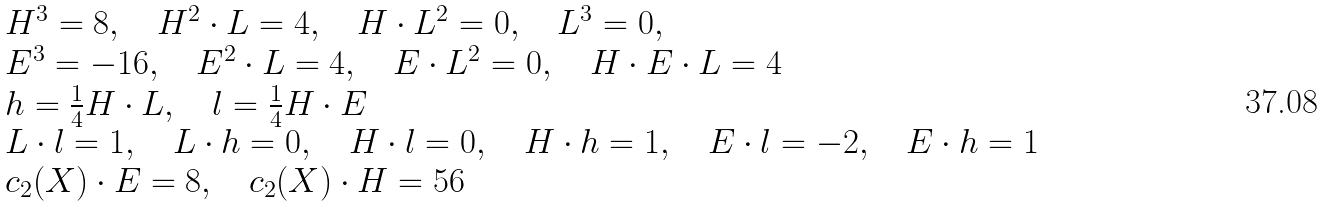<formula> <loc_0><loc_0><loc_500><loc_500>\begin{array} { l } H ^ { 3 } = 8 , \quad H ^ { 2 } \cdot L = 4 , \quad H \cdot L ^ { 2 } = 0 , \quad L ^ { 3 } = 0 , \\ E ^ { 3 } = - 1 6 , \quad E ^ { 2 } \cdot L = 4 , \quad E \cdot L ^ { 2 } = 0 , \quad H \cdot E \cdot L = 4 \\ h = \frac { 1 } { 4 } H \cdot L , \quad l = \frac { 1 } { 4 } H \cdot E \\ L \cdot l = 1 , \quad L \cdot h = 0 , \quad H \cdot l = 0 , \quad H \cdot h = 1 , \quad E \cdot l = - 2 , \quad E \cdot h = 1 \\ c _ { 2 } ( X ) \cdot E = 8 , \quad c _ { 2 } ( X ) \cdot H = 5 6 \end{array}</formula> 